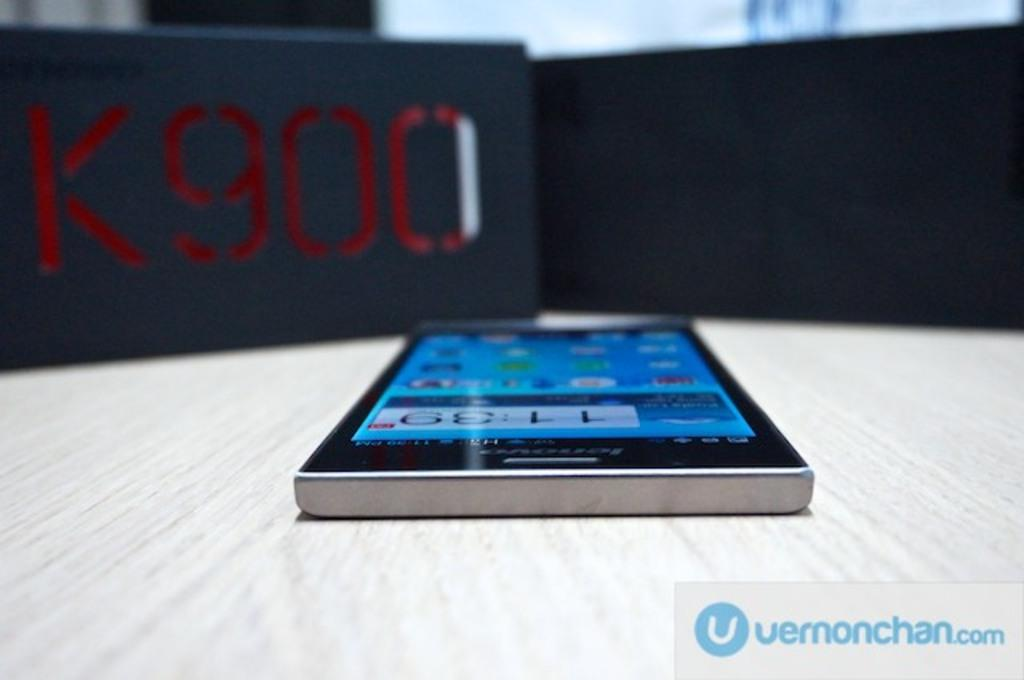<image>
Relay a brief, clear account of the picture shown. A cell phone screen of a k900 sitting on a white table. 